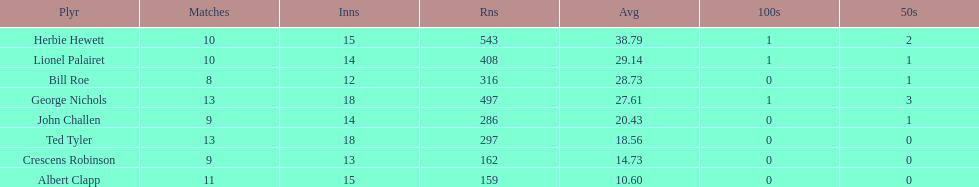What were the number of innings albert clapp had? 15. 